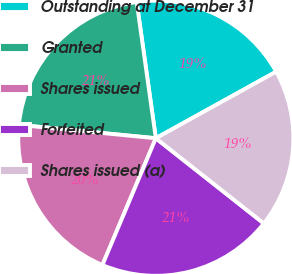Convert chart. <chart><loc_0><loc_0><loc_500><loc_500><pie_chart><fcel>Outstanding at December 31<fcel>Granted<fcel>Shares issued<fcel>Forfeited<fcel>Shares issued (a)<nl><fcel>19.18%<fcel>21.23%<fcel>20.2%<fcel>20.72%<fcel>18.67%<nl></chart> 